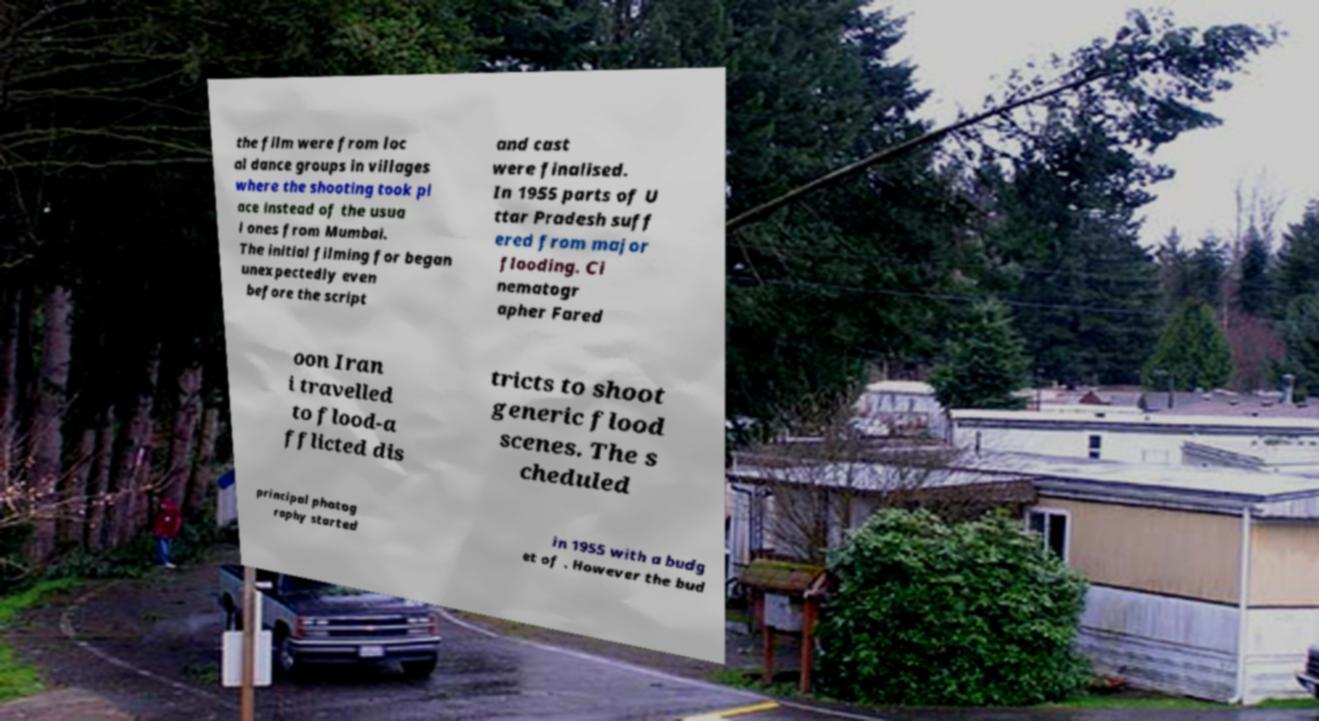Please read and relay the text visible in this image. What does it say? the film were from loc al dance groups in villages where the shooting took pl ace instead of the usua l ones from Mumbai. The initial filming for began unexpectedly even before the script and cast were finalised. In 1955 parts of U ttar Pradesh suff ered from major flooding. Ci nematogr apher Fared oon Iran i travelled to flood-a fflicted dis tricts to shoot generic flood scenes. The s cheduled principal photog raphy started in 1955 with a budg et of . However the bud 